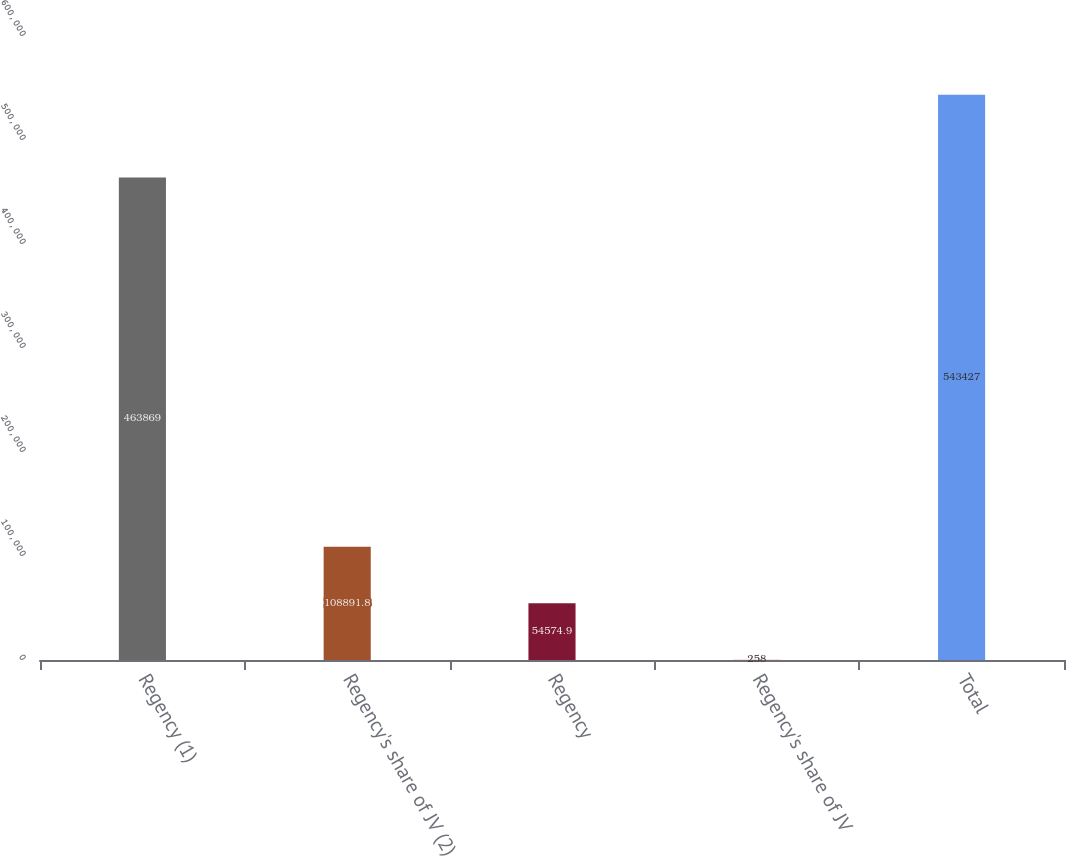Convert chart to OTSL. <chart><loc_0><loc_0><loc_500><loc_500><bar_chart><fcel>Regency (1)<fcel>Regency's share of JV (2)<fcel>Regency<fcel>Regency's share of JV<fcel>Total<nl><fcel>463869<fcel>108892<fcel>54574.9<fcel>258<fcel>543427<nl></chart> 